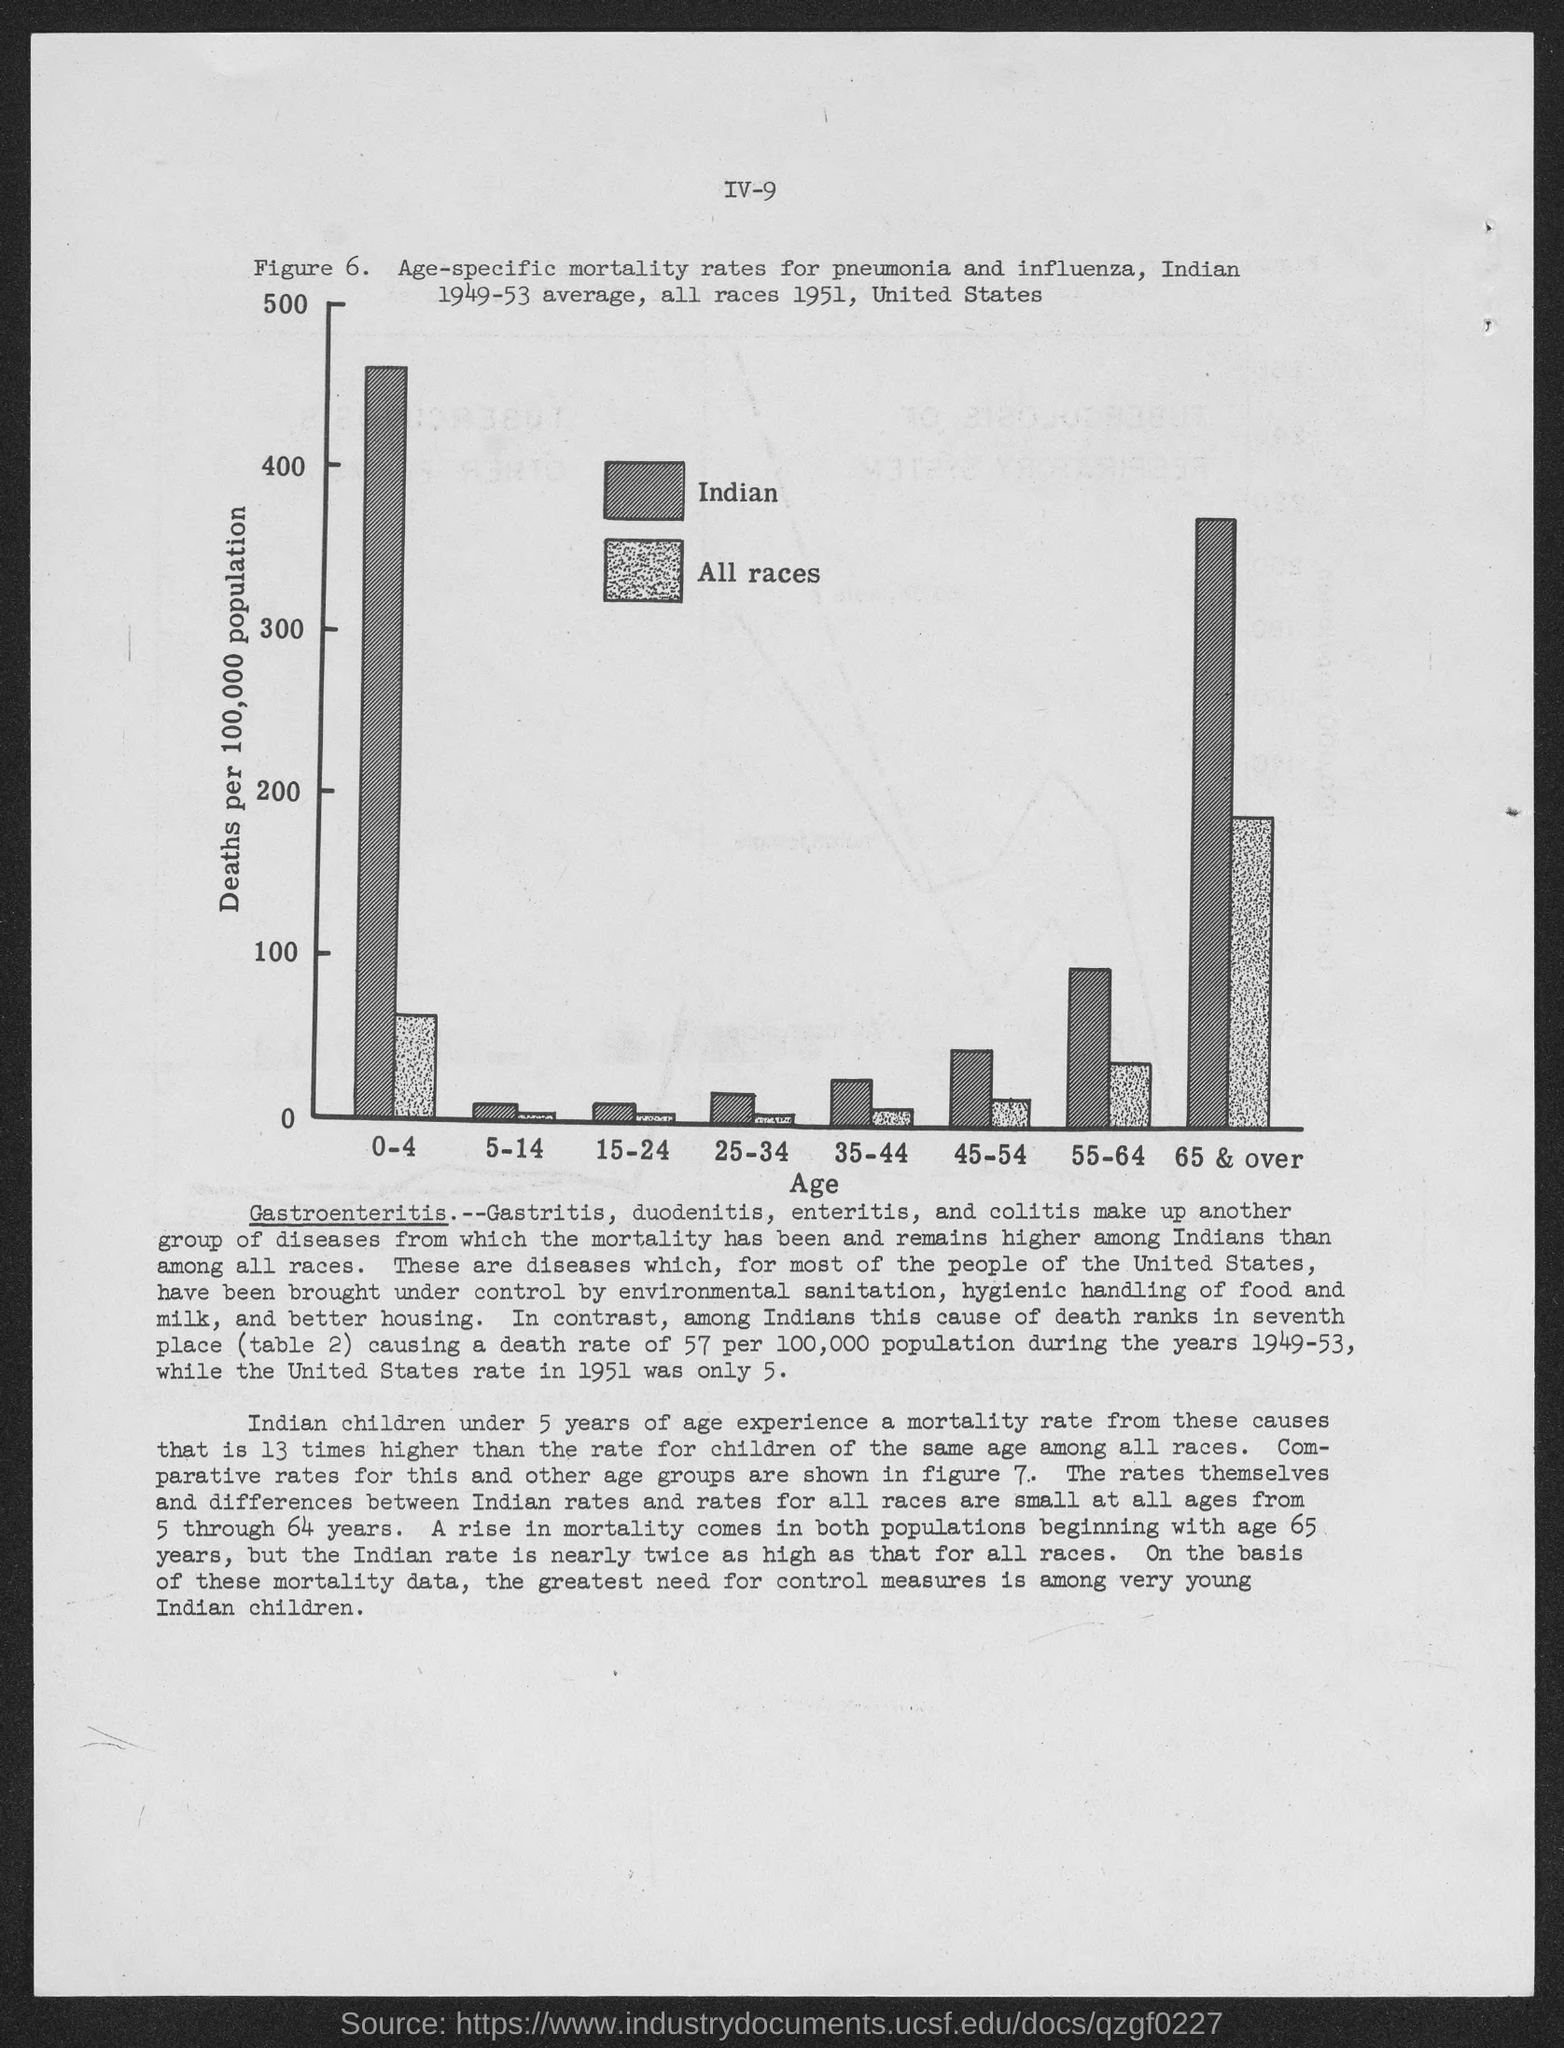Indicate a few pertinent items in this graphic. What is the number?" the figure asked. "It is six," the figure replied. The x-axis in the figure shows age, which is what is given. 